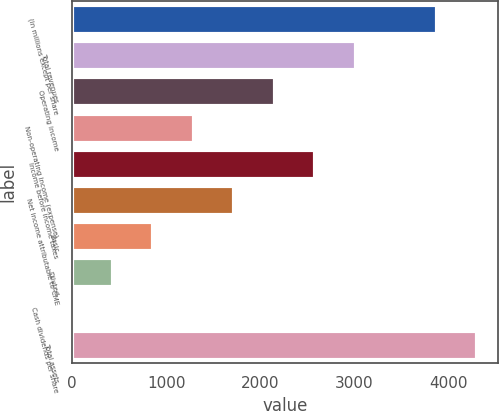<chart> <loc_0><loc_0><loc_500><loc_500><bar_chart><fcel>(in millions except per share<fcel>Total revenues<fcel>Operating income<fcel>Non-operating income (expense)<fcel>Income before income taxes<fcel>Net income attributable to CME<fcel>Basic<fcel>Diluted<fcel>Cash dividends per share<fcel>Total assets<nl><fcel>3876.12<fcel>3015.32<fcel>2154.52<fcel>1293.72<fcel>2584.92<fcel>1724.12<fcel>863.32<fcel>432.92<fcel>2.52<fcel>4306.52<nl></chart> 